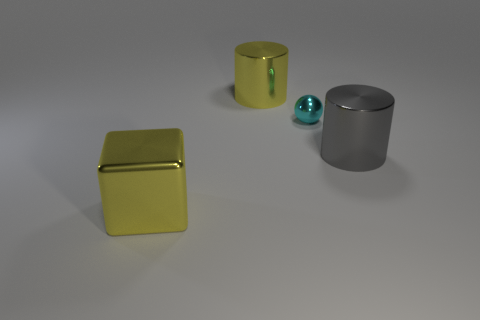Add 3 big cyan cylinders. How many objects exist? 7 Subtract all spheres. How many objects are left? 3 Subtract 0 red cubes. How many objects are left? 4 Subtract all cyan balls. Subtract all large metal cubes. How many objects are left? 2 Add 4 big shiny cylinders. How many big shiny cylinders are left? 6 Add 4 small brown spheres. How many small brown spheres exist? 4 